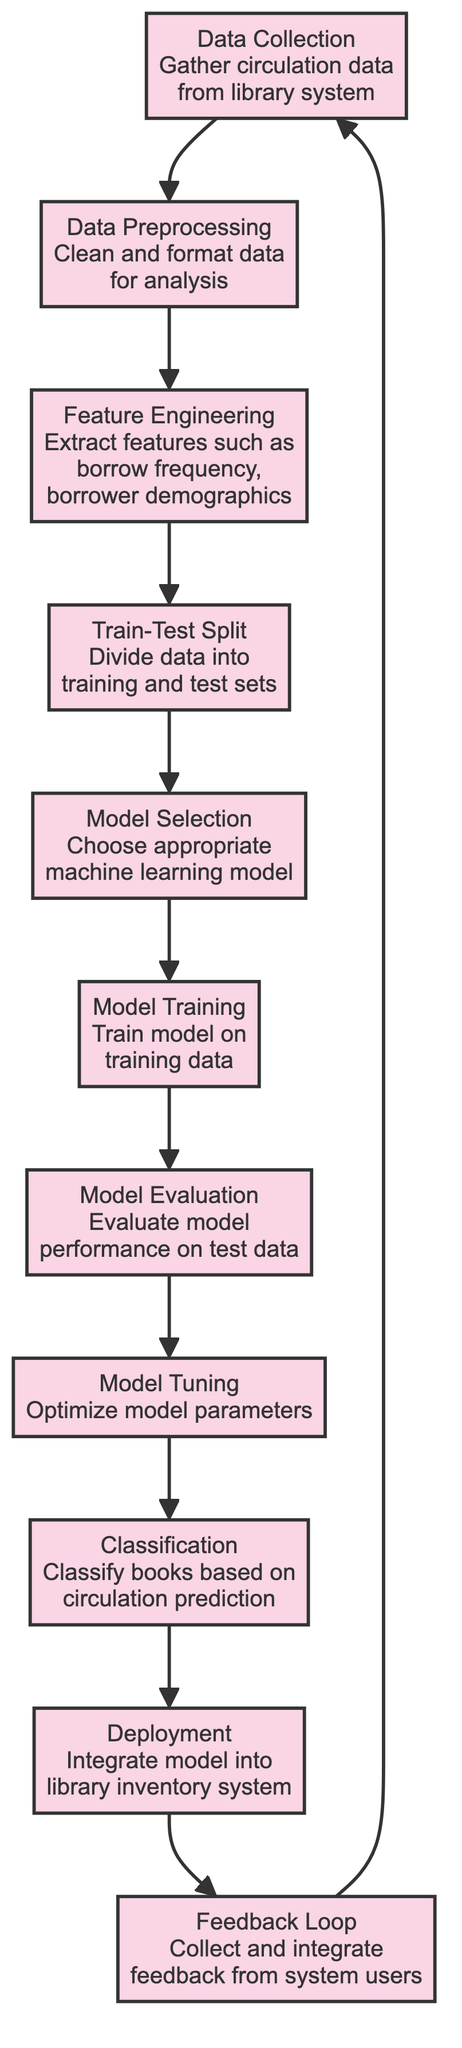What is the first step in the diagram? The first node in the diagram, "Data Collection," is where circulation data is gathered from the library system.
Answer: Data Collection How many nodes are present in the diagram? By counting all the nodes represented in the diagram, we find there are eleven nodes in total.
Answer: Eleven What process follows "Feature Engineering"? According to the flow in the diagram, the next step after "Feature Engineering" is "Train-Test Split."
Answer: Train-Test Split What does "Model Tuning" aim to achieve? "Model Tuning" is intended to optimize model parameters for better performance.
Answer: Optimize model parameters Which node leads to the "Classification" stage? The node "Model Tuning" directly leads to the "Classification" stage in the diagram.
Answer: Model Tuning What is integrated into the library inventory system during deployment? The entire trained model from the classification process is integrated into the library inventory system during deployment.
Answer: Model What is the purpose of the feedback loop? The feedback loop serves to collect and integrate feedback from system users, which is then used to enhance future data collection.
Answer: Collect and integrate feedback Which node indicates the evaluation of model performance? The node labeled "Model Evaluation" indicates the assessment of how well the model performs on the test data.
Answer: Model Evaluation What stage comes after "Model Training"? After "Model Training," the next stage as per the diagram is "Model Evaluation."
Answer: Model Evaluation 